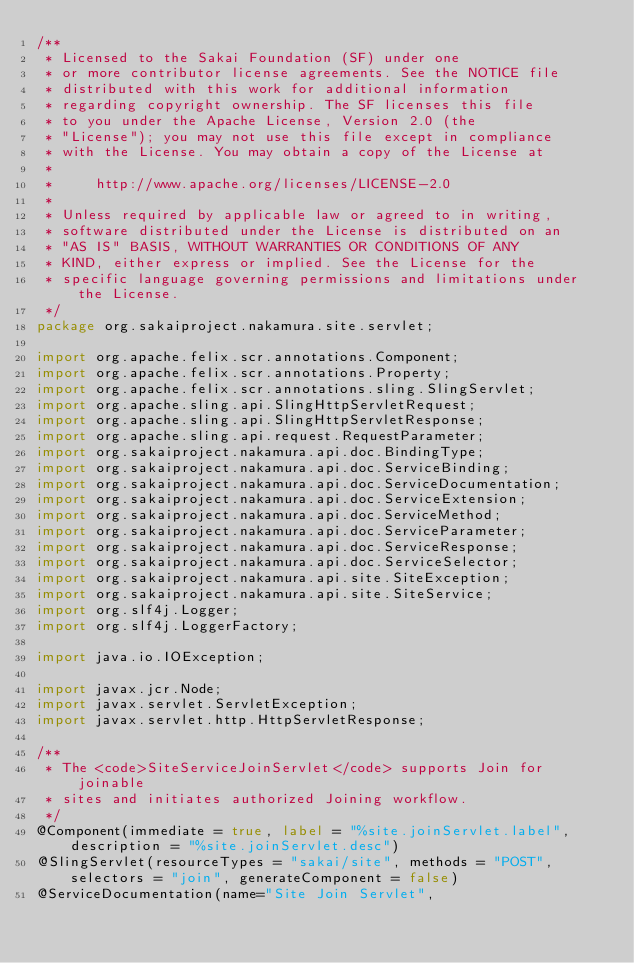<code> <loc_0><loc_0><loc_500><loc_500><_Java_>/**
 * Licensed to the Sakai Foundation (SF) under one
 * or more contributor license agreements. See the NOTICE file
 * distributed with this work for additional information
 * regarding copyright ownership. The SF licenses this file
 * to you under the Apache License, Version 2.0 (the
 * "License"); you may not use this file except in compliance
 * with the License. You may obtain a copy of the License at
 *
 *     http://www.apache.org/licenses/LICENSE-2.0
 *
 * Unless required by applicable law or agreed to in writing,
 * software distributed under the License is distributed on an
 * "AS IS" BASIS, WITHOUT WARRANTIES OR CONDITIONS OF ANY
 * KIND, either express or implied. See the License for the
 * specific language governing permissions and limitations under the License.
 */
package org.sakaiproject.nakamura.site.servlet;

import org.apache.felix.scr.annotations.Component;
import org.apache.felix.scr.annotations.Property;
import org.apache.felix.scr.annotations.sling.SlingServlet;
import org.apache.sling.api.SlingHttpServletRequest;
import org.apache.sling.api.SlingHttpServletResponse;
import org.apache.sling.api.request.RequestParameter;
import org.sakaiproject.nakamura.api.doc.BindingType;
import org.sakaiproject.nakamura.api.doc.ServiceBinding;
import org.sakaiproject.nakamura.api.doc.ServiceDocumentation;
import org.sakaiproject.nakamura.api.doc.ServiceExtension;
import org.sakaiproject.nakamura.api.doc.ServiceMethod;
import org.sakaiproject.nakamura.api.doc.ServiceParameter;
import org.sakaiproject.nakamura.api.doc.ServiceResponse;
import org.sakaiproject.nakamura.api.doc.ServiceSelector;
import org.sakaiproject.nakamura.api.site.SiteException;
import org.sakaiproject.nakamura.api.site.SiteService;
import org.slf4j.Logger;
import org.slf4j.LoggerFactory;

import java.io.IOException;

import javax.jcr.Node;
import javax.servlet.ServletException;
import javax.servlet.http.HttpServletResponse;

/**
 * The <code>SiteServiceJoinServlet</code> supports Join for joinable
 * sites and initiates authorized Joining workflow.
 */
@Component(immediate = true, label = "%site.joinServlet.label", description = "%site.joinServlet.desc")
@SlingServlet(resourceTypes = "sakai/site", methods = "POST", selectors = "join", generateComponent = false)
@ServiceDocumentation(name="Site Join Servlet",</code> 